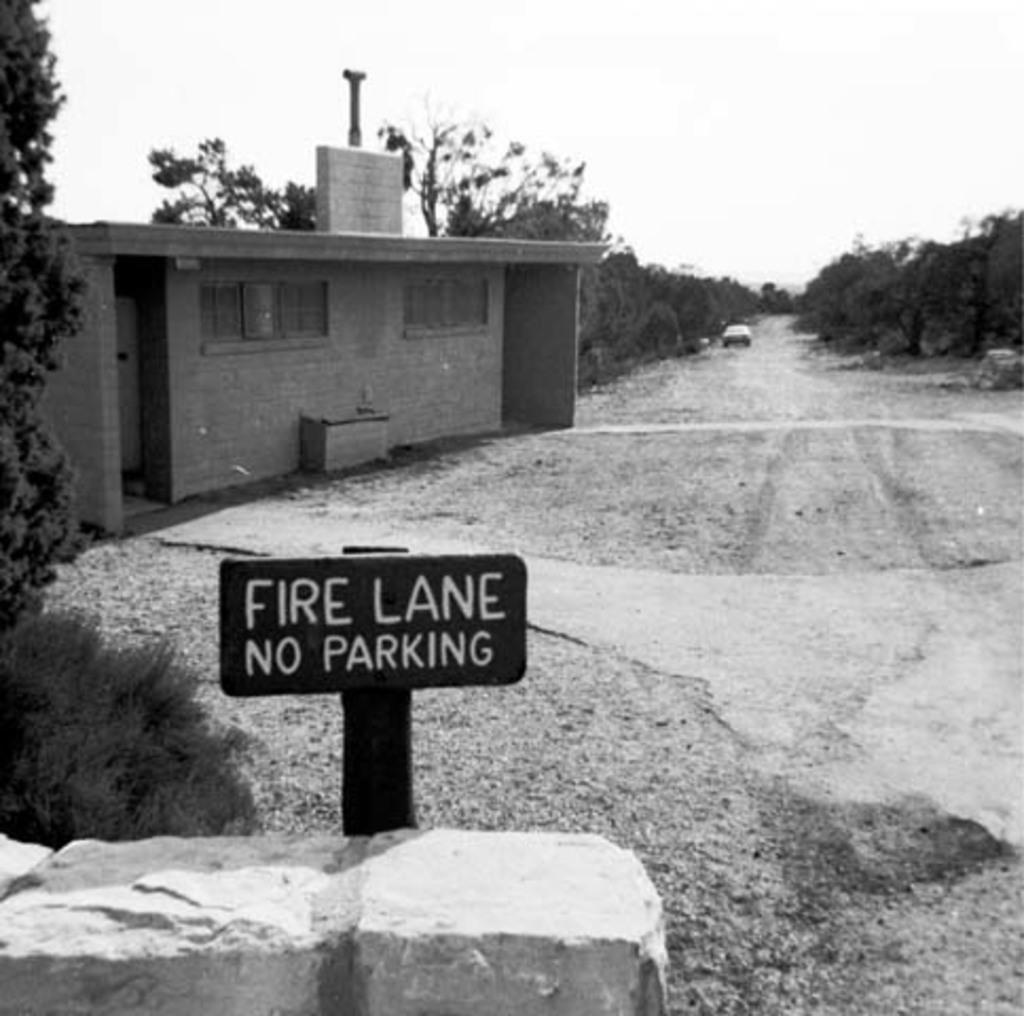Please provide a concise description of this image. In this image I can see there is a car on the road. And there is a building and a rod attached to the building. And there is a stone and a board with text. And there are trees and at the top there is a sky. 